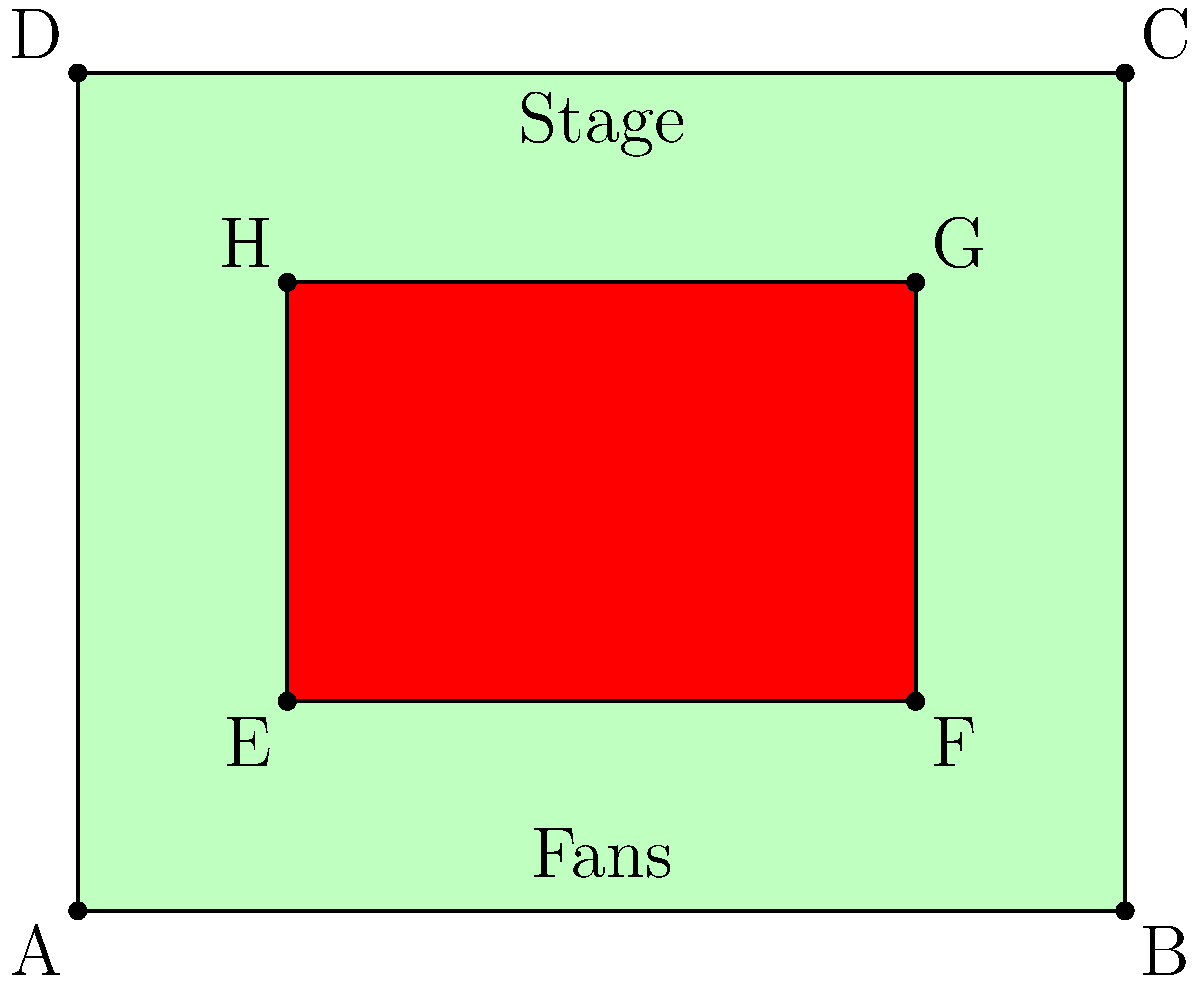At a Joan Jett outdoor performance, the entire venue is represented by a rectangle ABCD measuring 100m by 80m. The area occupied by fans is represented by the inner rectangle EFGH. If EF is 60m and EH is 40m, what percentage of the total venue area is occupied by fans? To solve this problem, let's follow these steps:

1. Calculate the total area of the venue (rectangle ABCD):
   Area of ABCD = 100m × 80m = 8000 m²

2. Calculate the area occupied by fans (rectangle EFGH):
   Area of EFGH = 60m × 40m = 2400 m²

3. Calculate the percentage of the area occupied by fans:
   Percentage = (Area occupied by fans / Total area) × 100
               = (2400 m² / 8000 m²) × 100
               = 0.3 × 100
               = 30%

Therefore, the fans occupy 30% of the total venue area.
Answer: 30% 